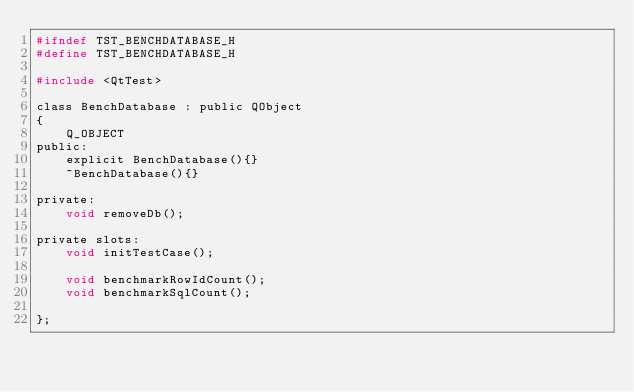Convert code to text. <code><loc_0><loc_0><loc_500><loc_500><_C_>#ifndef TST_BENCHDATABASE_H
#define TST_BENCHDATABASE_H

#include <QtTest>

class BenchDatabase : public QObject
{
    Q_OBJECT
public:
    explicit BenchDatabase(){}
    ~BenchDatabase(){}

private:
    void removeDb();

private slots:
    void initTestCase();

    void benchmarkRowIdCount();
    void benchmarkSqlCount();

};
</code> 